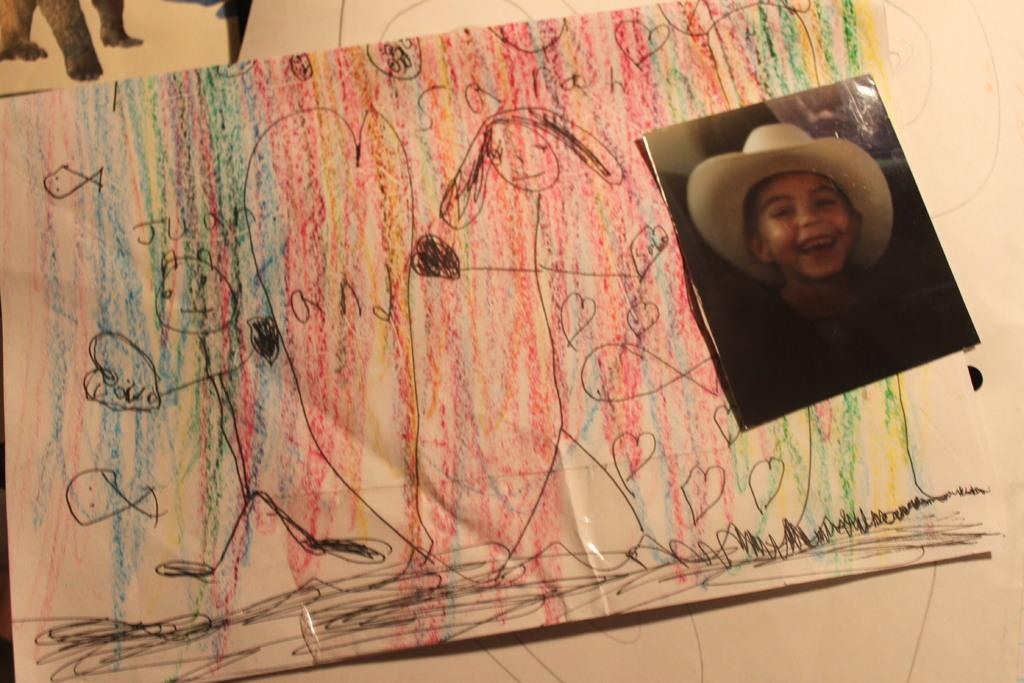What type of visual representation is present in the image? The image contains a chart. What is featured on the chart? The chart has a drawing on it. What other type of visual representation is present in the image? The image contains a photograph. What can be seen in the photograph? There is a picture of a kid in the photograph. Where are the animal legs located in the image? The animal legs are depicted in the top left of the image. What type of kite is being flown by the kid in the image? There is no kite present in the image; it features a chart, a photograph with a picture of a kid, and animal legs in the top left corner. How does the rail contribute to the overall composition of the image? There is no rail present in the image; it only contains a chart, a photograph, and animal legs. 